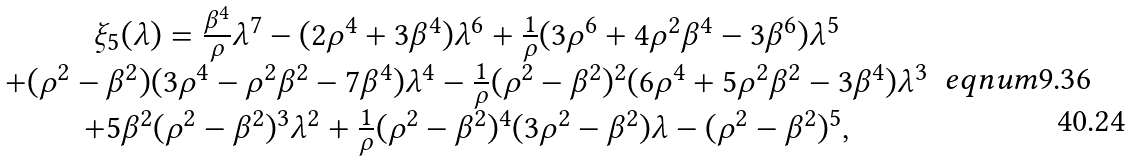<formula> <loc_0><loc_0><loc_500><loc_500>\begin{array} { c } \xi _ { 5 } ( \lambda ) = \frac { \beta ^ { 4 } } \rho \lambda ^ { 7 } - ( 2 \rho ^ { 4 } + 3 \beta ^ { 4 } ) \lambda ^ { 6 } + \frac { 1 } { \rho } ( 3 \rho ^ { 6 } + 4 \rho ^ { 2 } \beta ^ { 4 } - 3 \beta ^ { 6 } ) \lambda ^ { 5 } \\ + ( \rho ^ { 2 } - \beta ^ { 2 } ) ( 3 \rho ^ { 4 } - \rho ^ { 2 } \beta ^ { 2 } - 7 \beta ^ { 4 } ) \lambda ^ { 4 } - \frac { 1 } { \rho } ( \rho ^ { 2 } - \beta ^ { 2 } ) ^ { 2 } ( 6 \rho ^ { 4 } + 5 \rho ^ { 2 } \beta ^ { 2 } - 3 \beta ^ { 4 } ) \lambda ^ { 3 } \\ + 5 \beta ^ { 2 } ( \rho ^ { 2 } - \beta ^ { 2 } ) ^ { 3 } \lambda ^ { 2 } + \frac { 1 } { \rho } ( \rho ^ { 2 } - \beta ^ { 2 } ) ^ { 4 } ( 3 \rho ^ { 2 } - \beta ^ { 2 } ) \lambda - ( \rho ^ { 2 } - \beta ^ { 2 } ) ^ { 5 } , \end{array} \ e q n u m { 9 . 3 6 }</formula> 